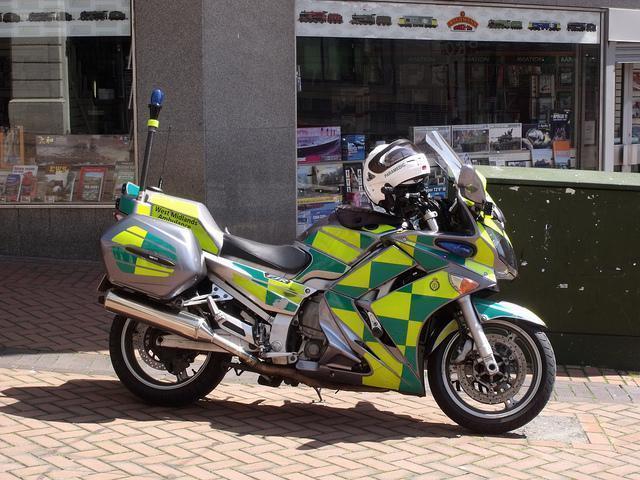The markings on the fairings of the motorcycle indicate that it belongs to which type of public organization?
Choose the right answer and clarify with the format: 'Answer: answer
Rationale: rationale.'
Options: Fire department, public health, public works, police. Answer: public health.
Rationale: Police vehicles have blue coloring on them. 